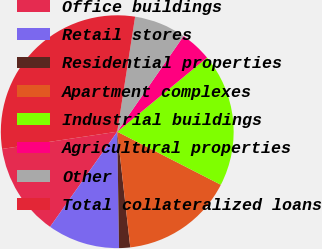<chart> <loc_0><loc_0><loc_500><loc_500><pie_chart><fcel>Office buildings<fcel>Retail stores<fcel>Residential properties<fcel>Apartment complexes<fcel>Industrial buildings<fcel>Agricultural properties<fcel>Other<fcel>Total collateralized loans<nl><fcel>12.85%<fcel>10.03%<fcel>1.54%<fcel>15.68%<fcel>18.51%<fcel>4.37%<fcel>7.2%<fcel>29.82%<nl></chart> 